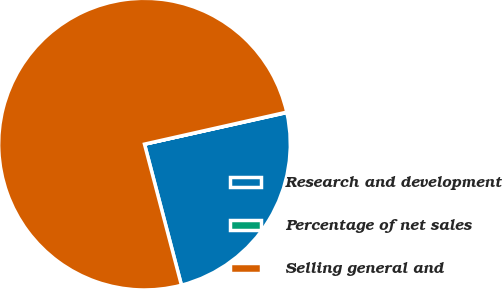<chart> <loc_0><loc_0><loc_500><loc_500><pie_chart><fcel>Research and development<fcel>Percentage of net sales<fcel>Selling general and<nl><fcel>24.4%<fcel>0.04%<fcel>75.55%<nl></chart> 